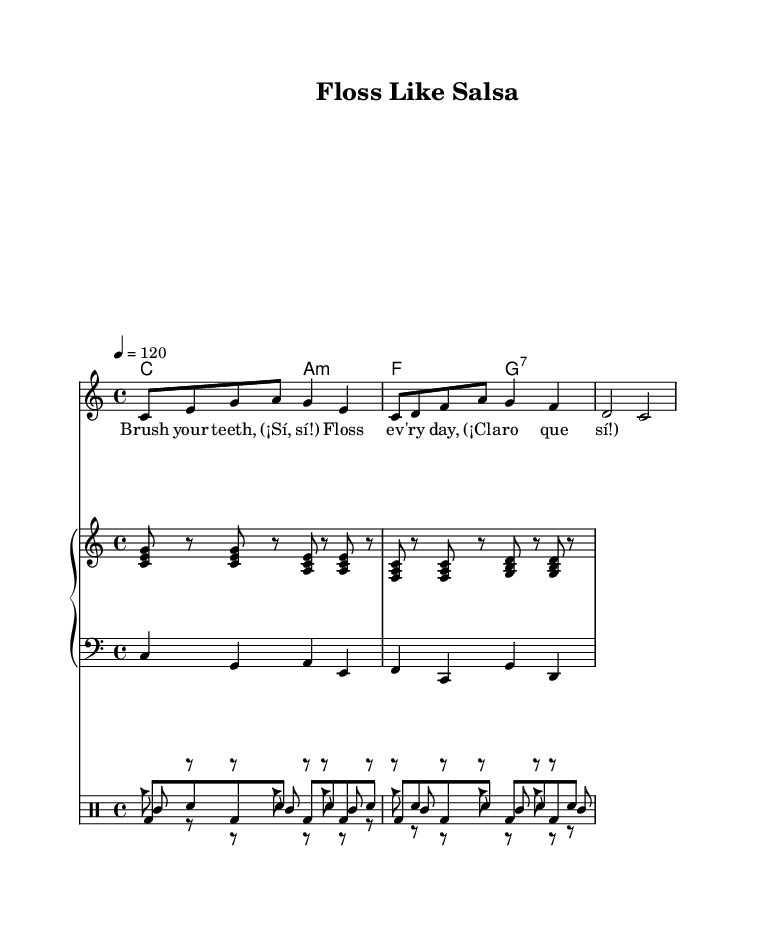What is the key signature of this music? The key signature is indicated to be 'C major' since it has no sharps or flats. This can be seen at the beginning of the staff where the key signature is notated.
Answer: C major What is the time signature of this music? The time signature is found at the beginning of the piece, indicated as 4/4. This means there are four beats in each measure, and the quarter note gets the beat.
Answer: 4/4 What is the tempo marking of this music? The tempo marking specifies that the piece should be played at a speed of 120 beats per minute, which is indicated as '4 = 120' at the start of the music.
Answer: 120 How many measures are in the melody? The melody has a total of three measures, which can be counted through the music notation where every group of notes separated by vertical lines indicates one measure.
Answer: 3 What type of dance rhythm is used in the percussion section? The percussion section uses traditional Latin-inspired dance rhythms that can be identified from the conga, cowbell, and claves drum patterns, which are characteristic of this genre.
Answer: Latin-inspired What do the lyrics suggest about oral hygiene? The lyrics emphasize the importance of regular dental care, suggesting that brushing and flossing are essential habits for students, indicated by the repeated phrases focusing on brushing and flossing.
Answer: Brush your teeth, Floss every day Which instrument plays the bass line? The bass line is played by the lower staff in the piano section, which employs a bass clef to indicate lower pitch notes and typically plays foundational harmonies.
Answer: Piano left hand 